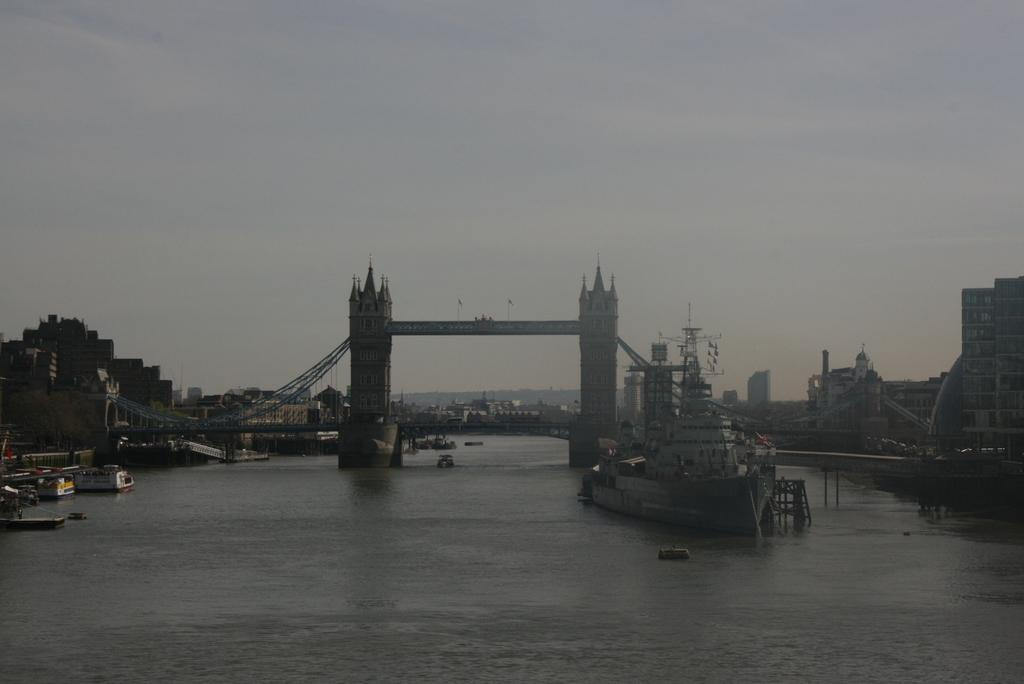What is the main feature of the image? The main feature of the image is water. What can be seen floating on the water? There are boats and a ship in the water. What famous landmark is visible in the image? The London Bridge is visible in the image. What is located behind the London Bridge? There are buildings behind the London Bridge. What part of the natural environment is visible in the image? The sky is visible in the image. What type of beef is being served at the restaurant in the image? There is no restaurant or beef present in the image; it features water, boats, a ship, the London Bridge, buildings, and the sky. 